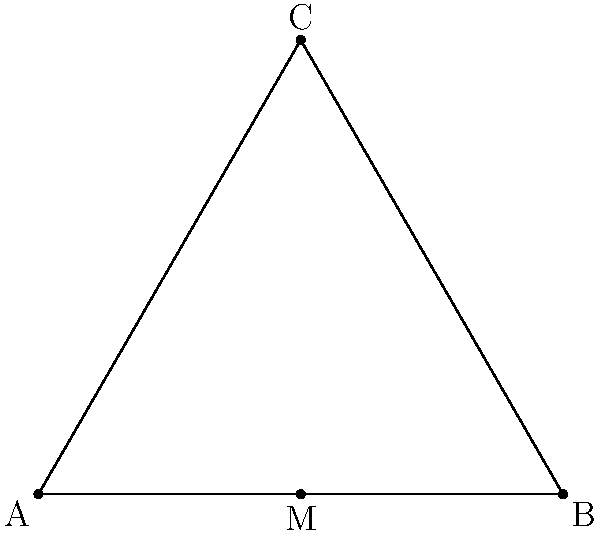Consider an equilateral triangle ABC with side length 1, and let M be the midpoint of side AB. The dihedral group $D_3$ acts on the triangle by rotations and reflections. How many distinct points are in the orbit of point M under this group action? To determine the number of distinct points in the orbit of M, we need to apply all elements of $D_3$ to M and count the unique results. Let's break this down step-by-step:

1) The dihedral group $D_3$ has 6 elements:
   - Identity (e)
   - Rotations by 120° and 240° (r and r²)
   - Reflections about the three axes of symmetry (s, sr, sr²)

2) Let's apply each element to M:
   - e(M) = M (identity)
   - r(M) = midpoint of BC
   - r²(M) = midpoint of AC
   - s(M) = M (reflection about AB)
   - sr(M) = midpoint of BC (same as r(M))
   - sr²(M) = midpoint of AC (same as r²(M))

3) Counting the unique points:
   - M (midpoint of AB)
   - Midpoint of BC
   - Midpoint of AC

Therefore, the orbit of M under the action of $D_3$ contains 3 distinct points.

This result aligns with the concept of orbits in group theory, where the orbit of an element under a group action consists of all elements that can be reached by applying the group operations.
Answer: 3 